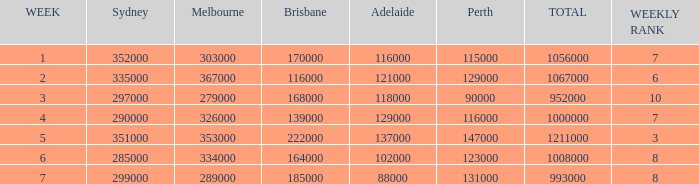How many viewers were there in Sydney for the episode when there were 334000 in Melbourne? 285000.0. 